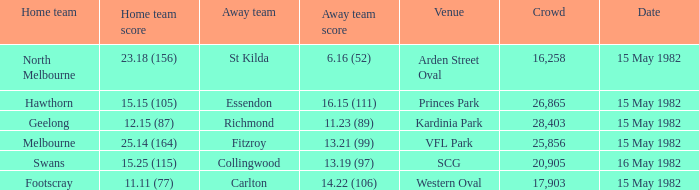What did the away team score when playing Footscray? 14.22 (106). 